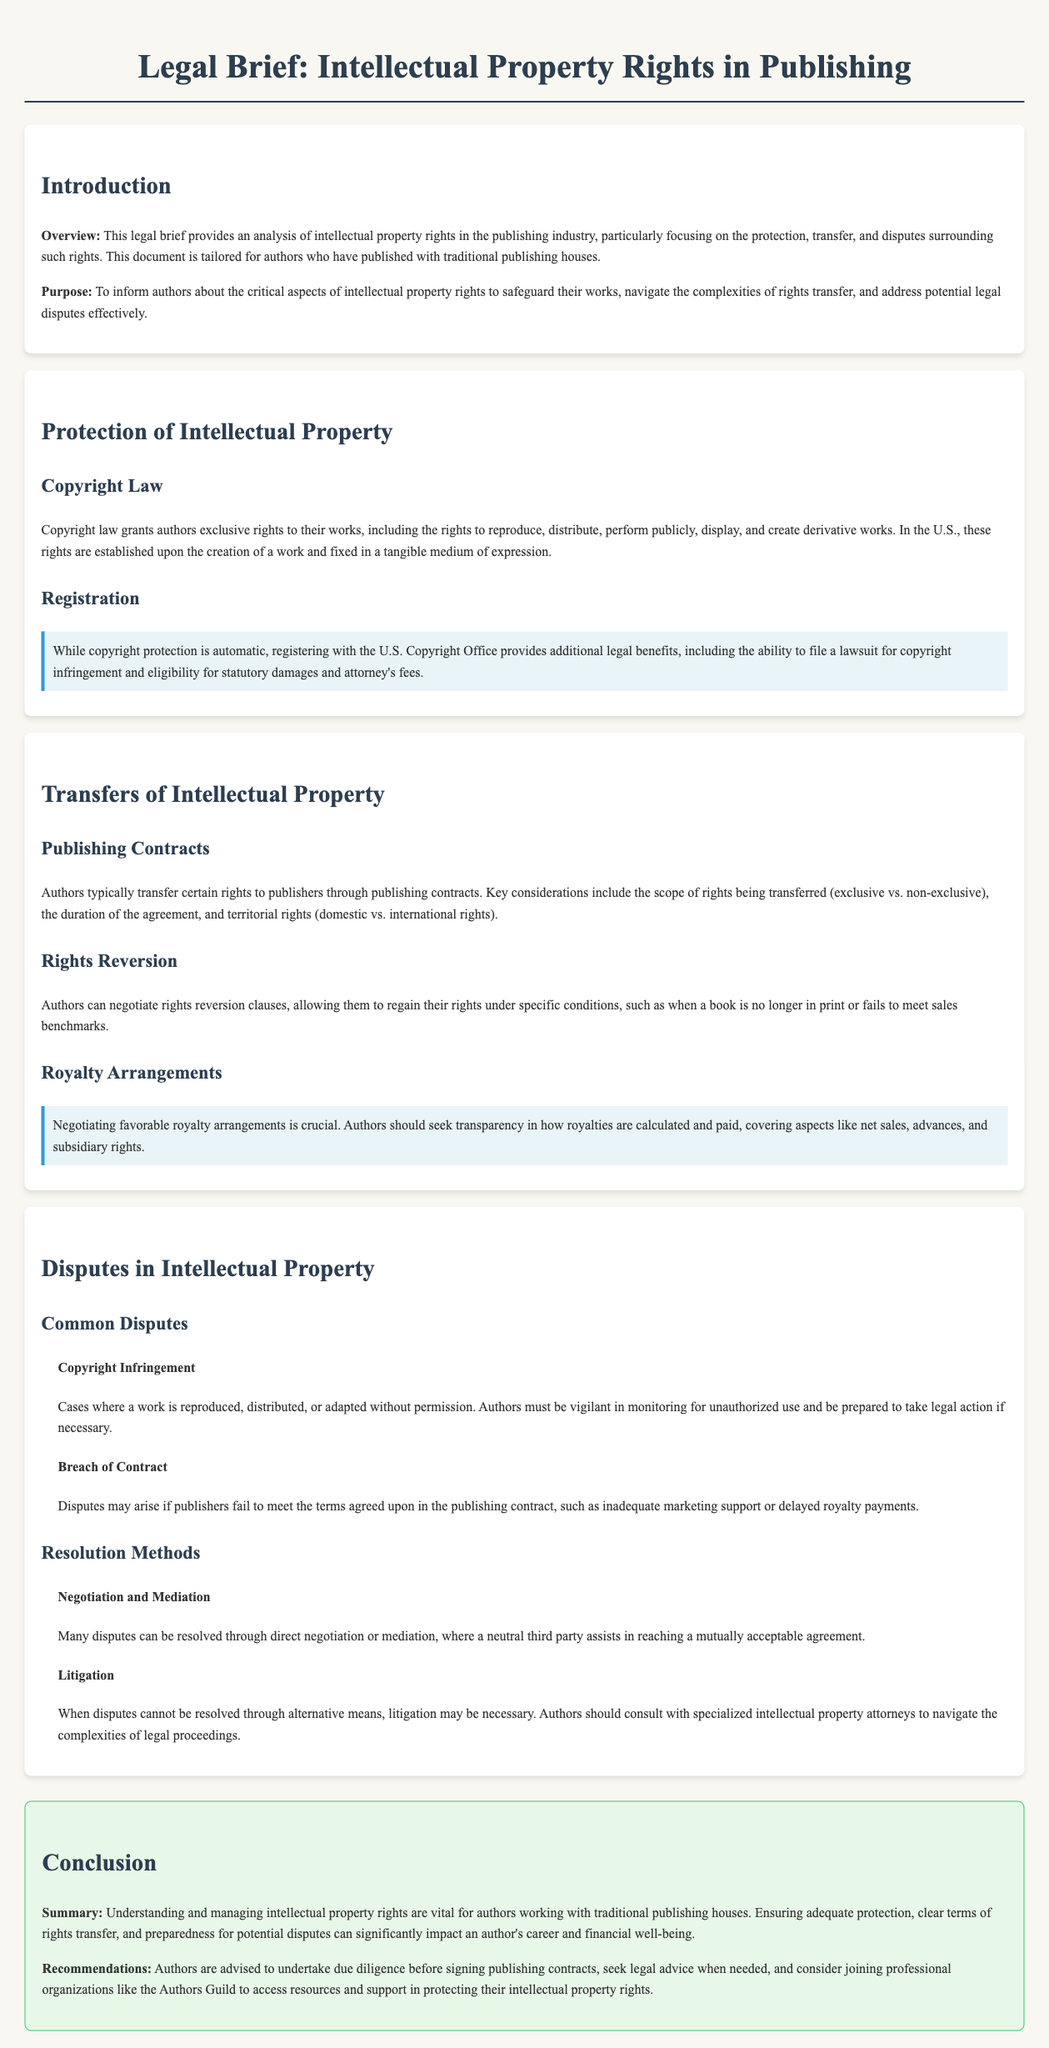What is the purpose of this legal brief? The purpose of the legal brief is to inform authors about critical aspects of intellectual property rights to safeguard their works, navigate the complexities of rights transfer, and address potential legal disputes effectively.
Answer: To inform authors about critical aspects of intellectual property rights What can authors do to enhance their copyright protection? Authors can enhance their copyright protection by registering with the U.S. Copyright Office.
Answer: Registering with the U.S. Copyright Office What type of contracts typically include rights transfers? Publishing contracts typically include rights transfers.
Answer: Publishing contracts What options do authors have for regaining rights? Authors can negotiate rights reversion clauses to regain rights under specific conditions.
Answer: Rights reversion clauses What are common disputes mentioned in the document? Common disputes include copyright infringement and breach of contract.
Answer: Copyright infringement and breach of contract What is a recommended method for resolving disputes? A recommended method for resolving disputes is negotiation and mediation.
Answer: Negotiation and mediation How should authors protect their intellectual property rights according to the recommendations? Authors are advised to undertake due diligence before signing publishing contracts.
Answer: Undertake due diligence before signing publishing contracts What additional support can authors seek for protecting their rights? Authors can consider joining professional organizations like the Authors Guild for support.
Answer: Authors Guild 